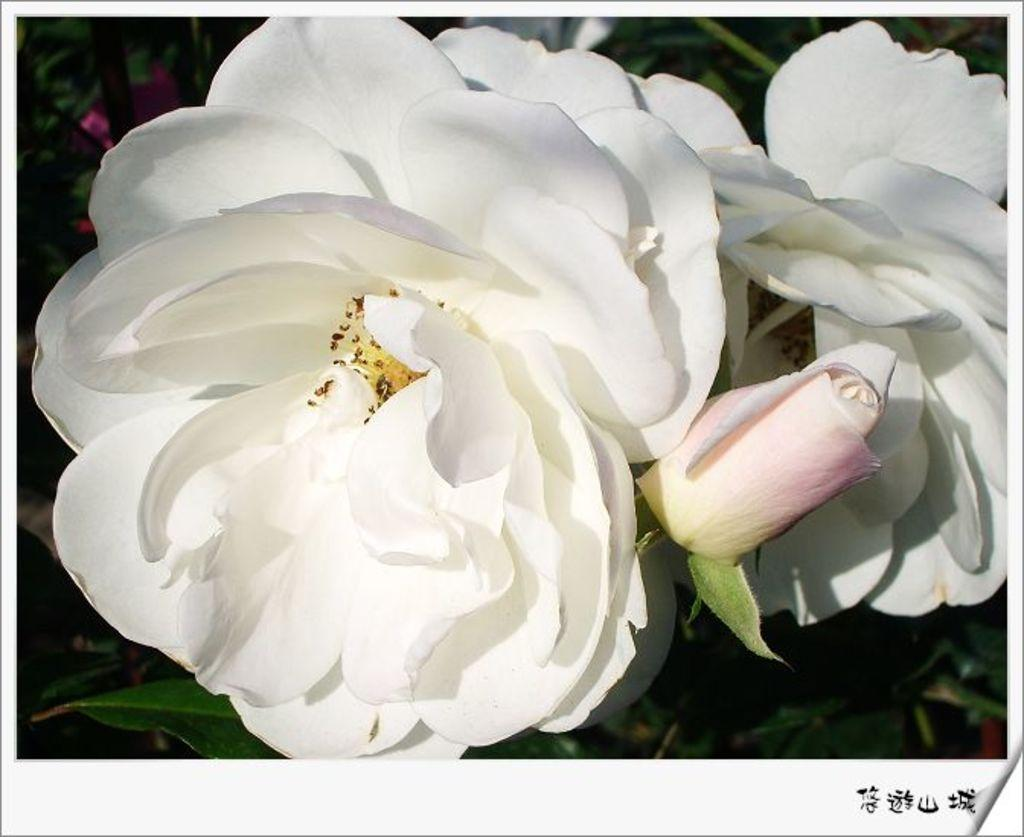What type of flowers are in the picture? There are white color flowers in the picture. Is there any text or writing on the image? Yes, there is something written on the image. How many dimes are scattered around the flowers in the image? There are no dimes present in the image; it only features white color flowers and writing. 